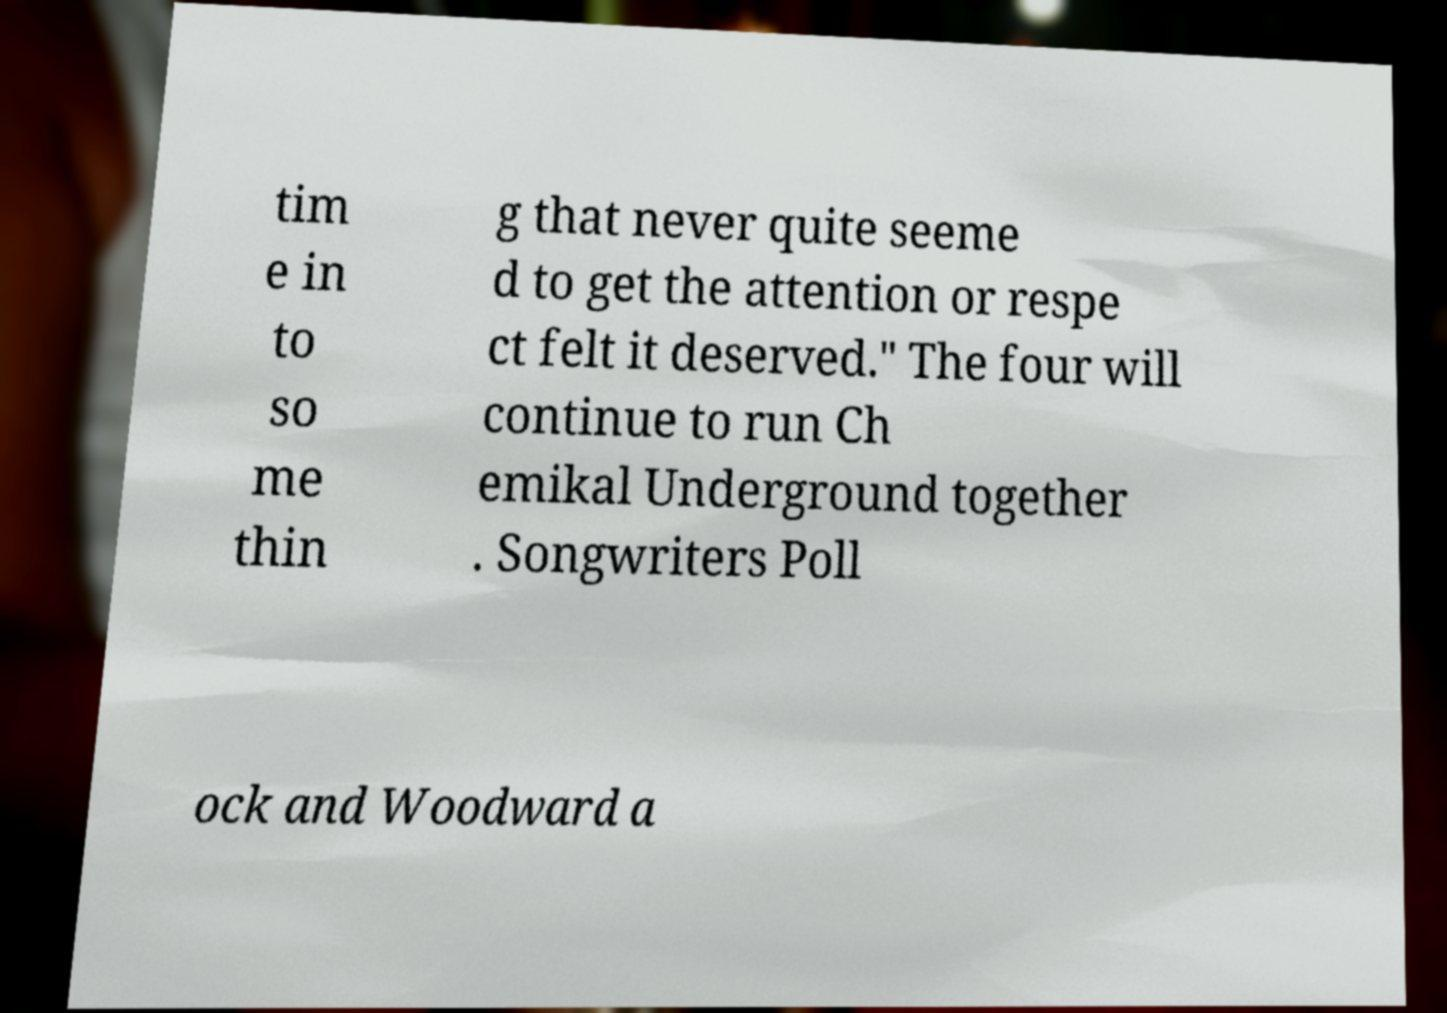Could you extract and type out the text from this image? tim e in to so me thin g that never quite seeme d to get the attention or respe ct felt it deserved." The four will continue to run Ch emikal Underground together . Songwriters Poll ock and Woodward a 